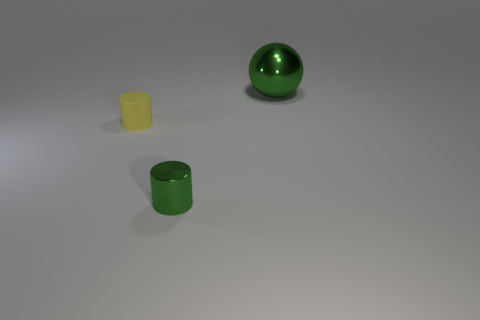Is there any other thing that has the same size as the green shiny ball?
Provide a short and direct response. No. What is the shape of the green thing that is left of the metal object to the right of the green object on the left side of the green ball?
Make the answer very short. Cylinder. The green thing in front of the green object behind the tiny green thing is made of what material?
Make the answer very short. Metal. There is another green object that is the same material as the tiny green object; what is its shape?
Give a very brief answer. Sphere. Is there anything else that is the same shape as the big green metal thing?
Keep it short and to the point. No. There is a metal cylinder; what number of green cylinders are to the left of it?
Keep it short and to the point. 0. Are any big red rubber balls visible?
Give a very brief answer. No. What is the color of the shiny object that is to the left of the green object that is on the right side of the green shiny object that is in front of the green ball?
Your answer should be very brief. Green. Are there any large balls on the left side of the metallic thing that is in front of the big green metal sphere?
Keep it short and to the point. No. There is a shiny object in front of the large green metal object; is it the same color as the shiny object behind the matte cylinder?
Make the answer very short. Yes. 